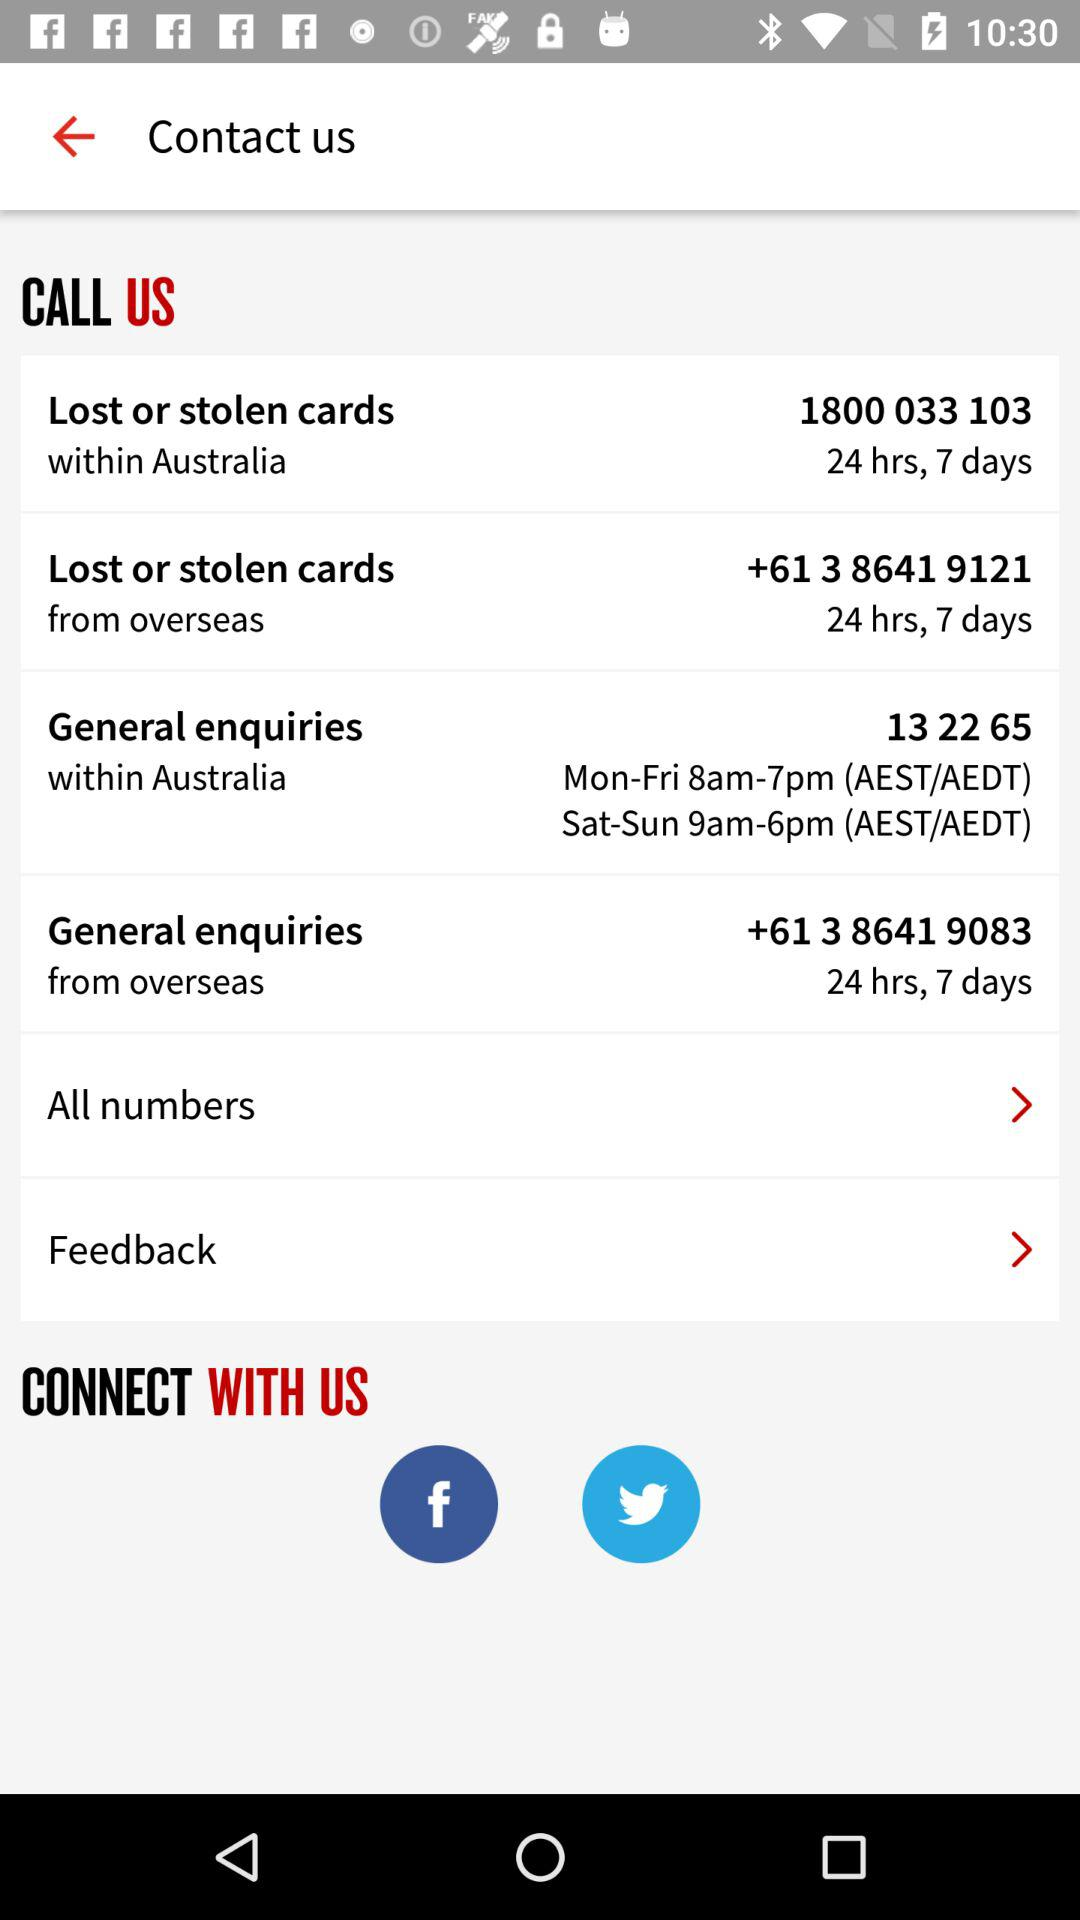What is the number to call for lost and stolen cards within Australia? The number is 1800 033 103. 